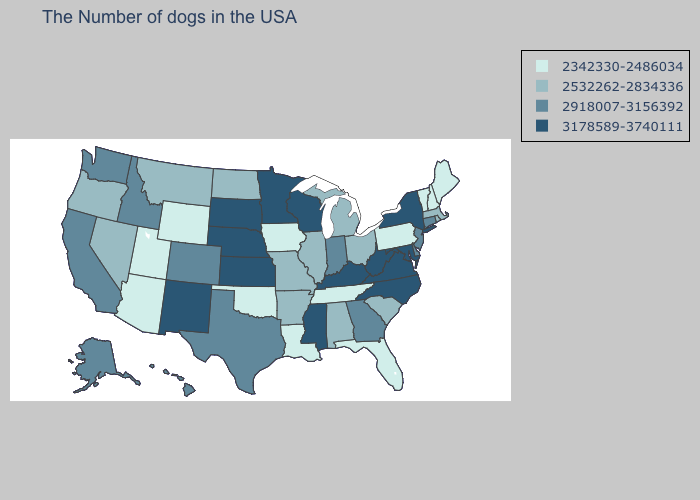Among the states that border California , does Arizona have the highest value?
Write a very short answer. No. Which states have the lowest value in the USA?
Write a very short answer. Maine, New Hampshire, Vermont, Pennsylvania, Florida, Tennessee, Louisiana, Iowa, Oklahoma, Wyoming, Utah, Arizona. What is the highest value in the USA?
Give a very brief answer. 3178589-3740111. Among the states that border South Dakota , does Nebraska have the highest value?
Be succinct. Yes. Name the states that have a value in the range 2918007-3156392?
Give a very brief answer. Connecticut, New Jersey, Delaware, Georgia, Indiana, Texas, Colorado, Idaho, California, Washington, Alaska, Hawaii. How many symbols are there in the legend?
Answer briefly. 4. Does Illinois have a lower value than Maryland?
Be succinct. Yes. Name the states that have a value in the range 2342330-2486034?
Quick response, please. Maine, New Hampshire, Vermont, Pennsylvania, Florida, Tennessee, Louisiana, Iowa, Oklahoma, Wyoming, Utah, Arizona. Which states have the highest value in the USA?
Keep it brief. New York, Maryland, Virginia, North Carolina, West Virginia, Kentucky, Wisconsin, Mississippi, Minnesota, Kansas, Nebraska, South Dakota, New Mexico. How many symbols are there in the legend?
Short answer required. 4. What is the value of Oklahoma?
Keep it brief. 2342330-2486034. Is the legend a continuous bar?
Write a very short answer. No. What is the value of Iowa?
Give a very brief answer. 2342330-2486034. What is the value of Arkansas?
Write a very short answer. 2532262-2834336. 